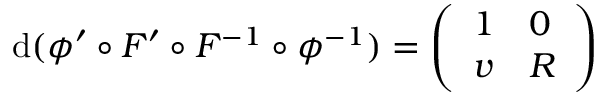Convert formula to latex. <formula><loc_0><loc_0><loc_500><loc_500>d ( \phi ^ { \prime } \circ F ^ { \prime } \circ F ^ { - 1 } \circ \phi ^ { - 1 } ) = \left ( \begin{array} { l l } { 1 } & { 0 } \\ { v } & { R } \end{array} \right )</formula> 